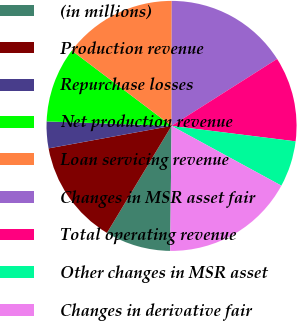Convert chart. <chart><loc_0><loc_0><loc_500><loc_500><pie_chart><fcel>(in millions)<fcel>Production revenue<fcel>Repurchase losses<fcel>Net production revenue<fcel>Loan servicing revenue<fcel>Changes in MSR asset fair<fcel>Total operating revenue<fcel>Other changes in MSR asset<fcel>Changes in derivative fair<nl><fcel>8.47%<fcel>13.48%<fcel>3.45%<fcel>9.72%<fcel>14.73%<fcel>15.98%<fcel>10.97%<fcel>5.96%<fcel>17.24%<nl></chart> 